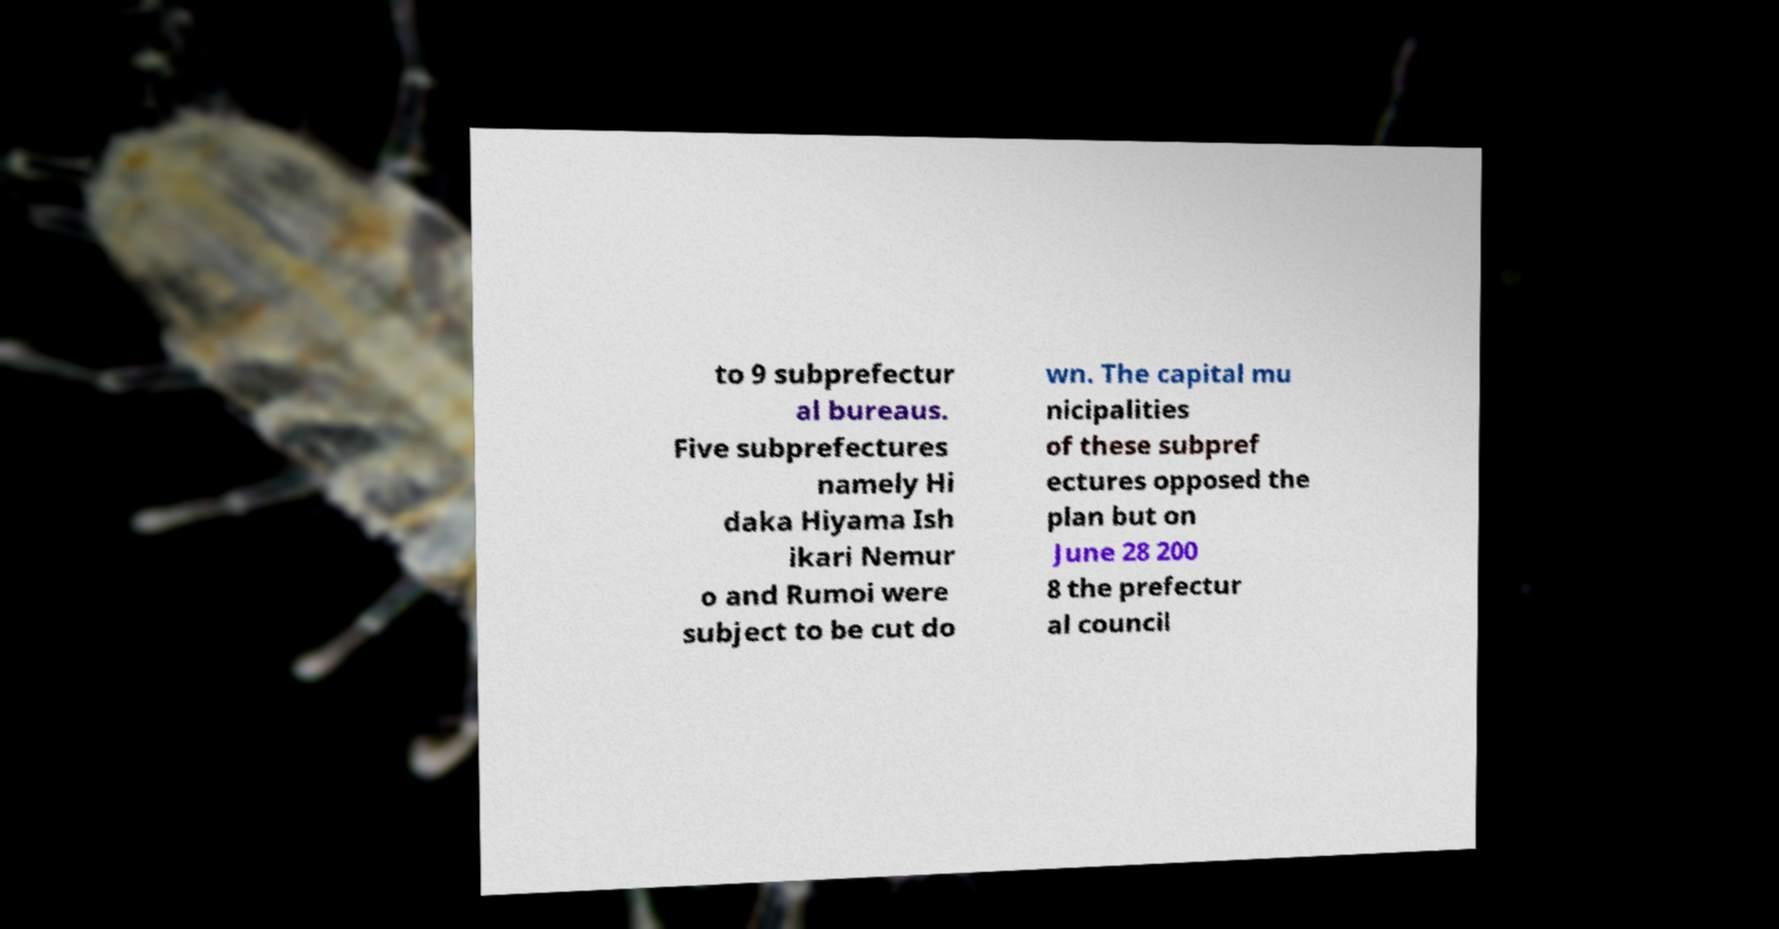Could you extract and type out the text from this image? to 9 subprefectur al bureaus. Five subprefectures namely Hi daka Hiyama Ish ikari Nemur o and Rumoi were subject to be cut do wn. The capital mu nicipalities of these subpref ectures opposed the plan but on June 28 200 8 the prefectur al council 